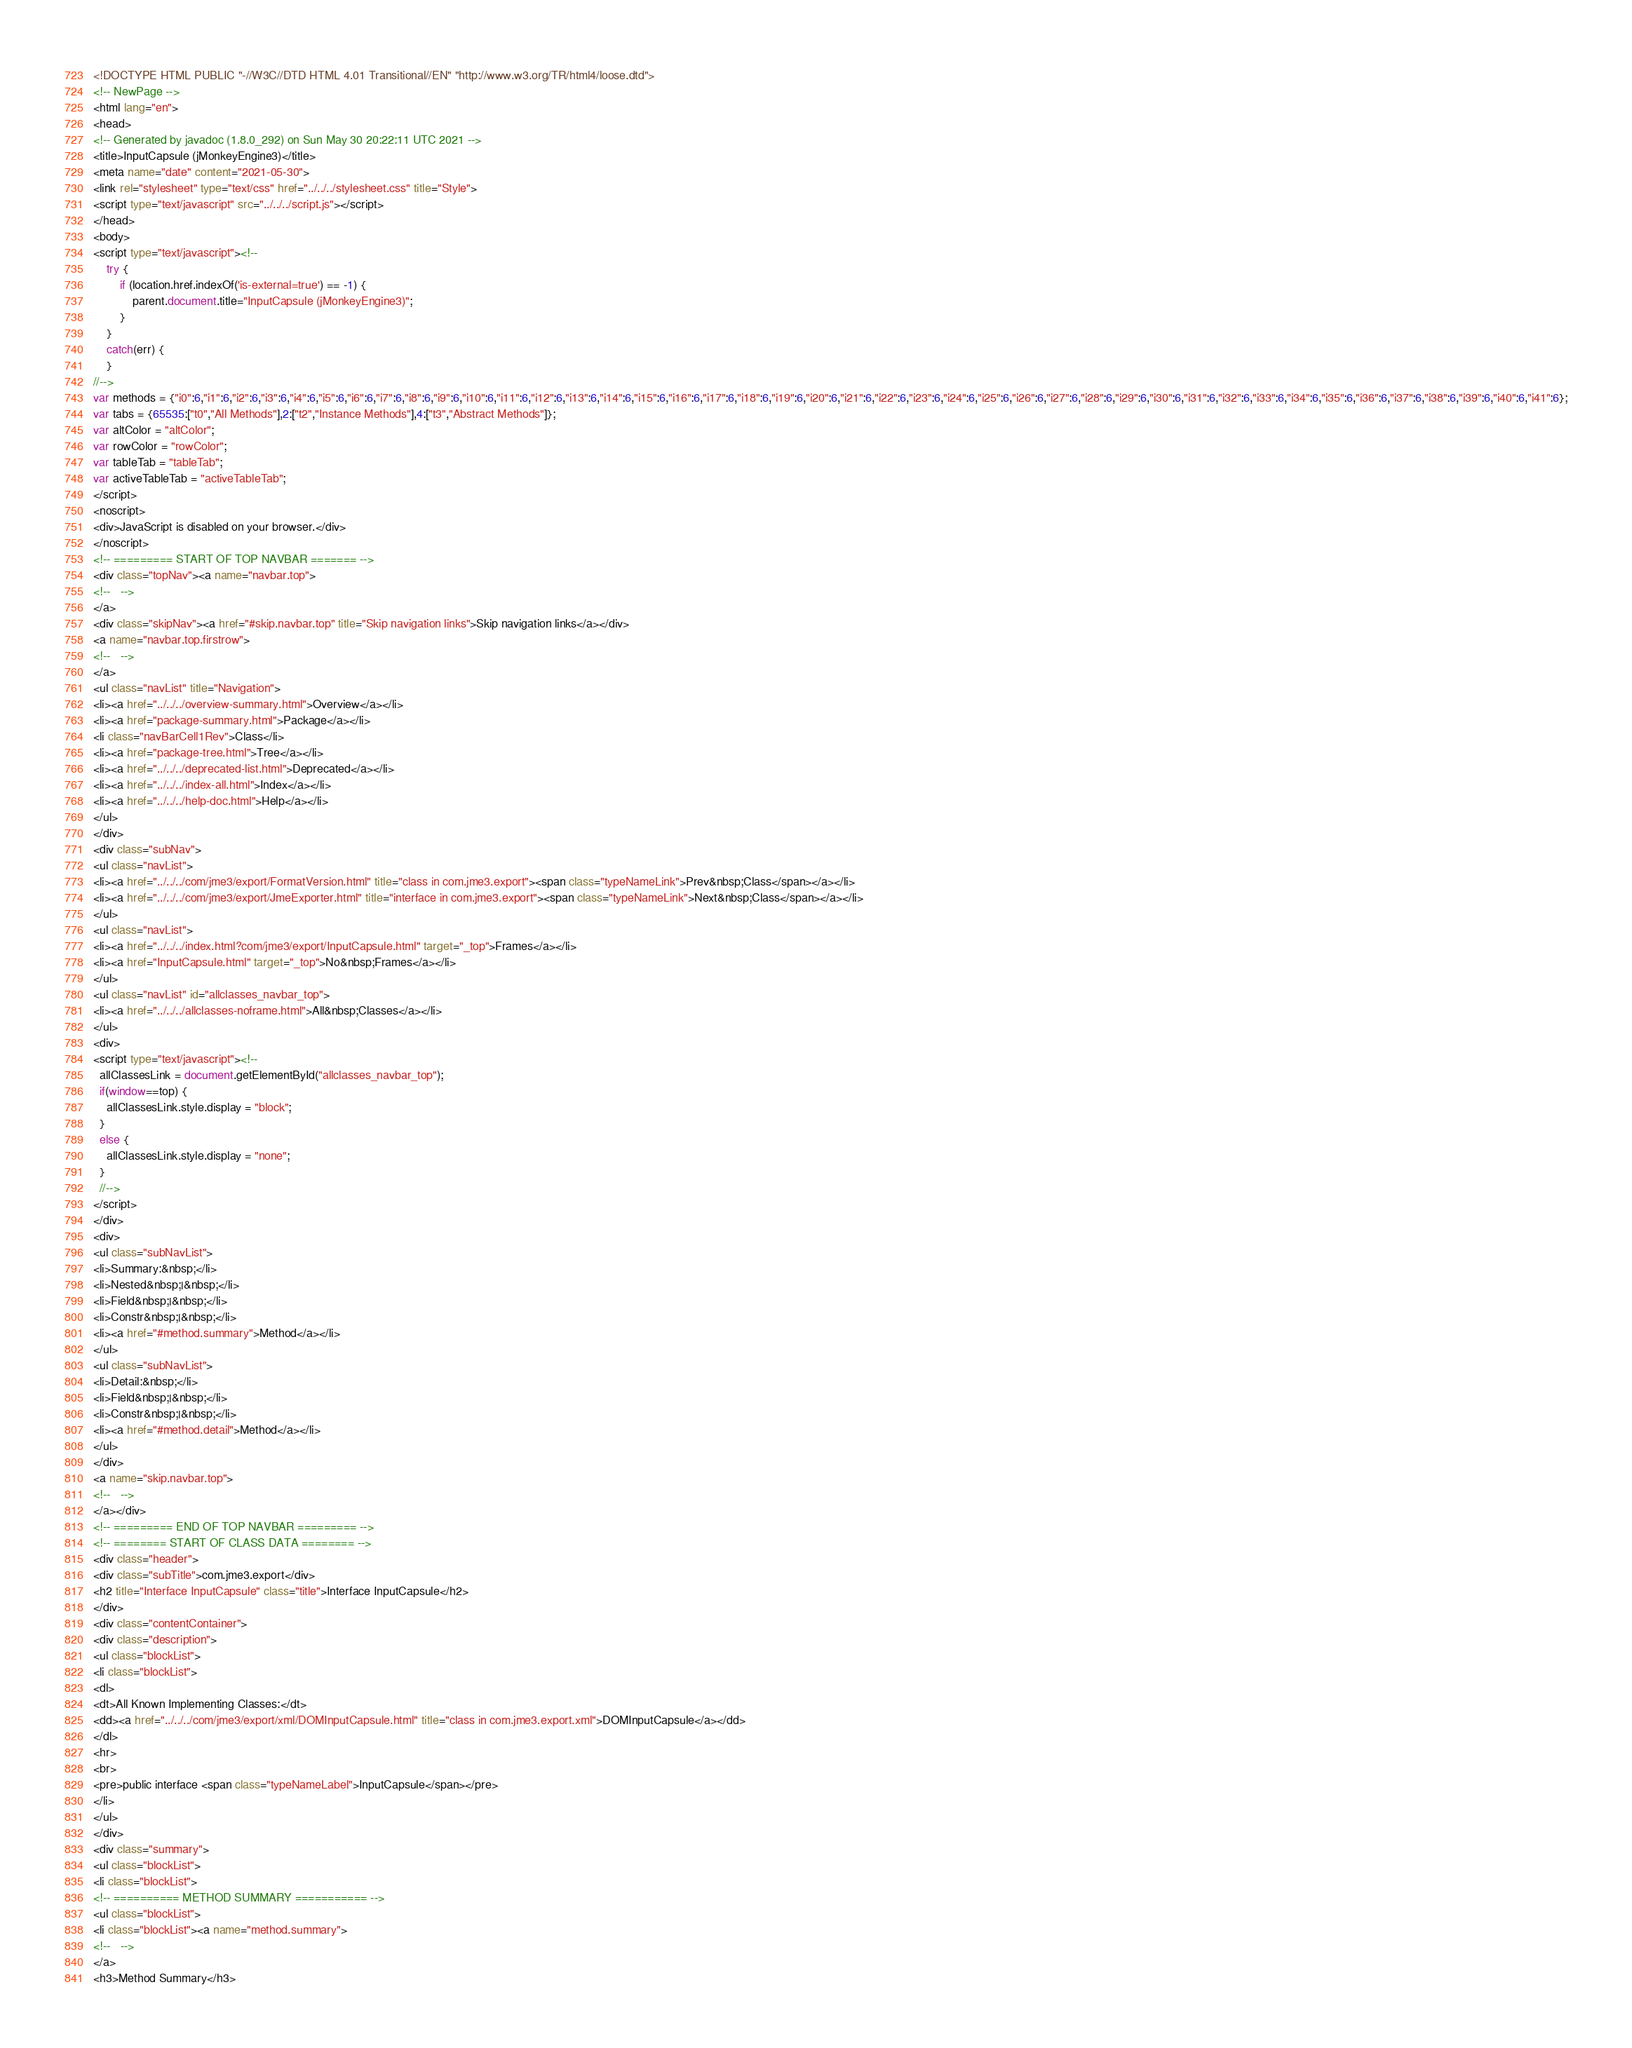<code> <loc_0><loc_0><loc_500><loc_500><_HTML_><!DOCTYPE HTML PUBLIC "-//W3C//DTD HTML 4.01 Transitional//EN" "http://www.w3.org/TR/html4/loose.dtd">
<!-- NewPage -->
<html lang="en">
<head>
<!-- Generated by javadoc (1.8.0_292) on Sun May 30 20:22:11 UTC 2021 -->
<title>InputCapsule (jMonkeyEngine3)</title>
<meta name="date" content="2021-05-30">
<link rel="stylesheet" type="text/css" href="../../../stylesheet.css" title="Style">
<script type="text/javascript" src="../../../script.js"></script>
</head>
<body>
<script type="text/javascript"><!--
    try {
        if (location.href.indexOf('is-external=true') == -1) {
            parent.document.title="InputCapsule (jMonkeyEngine3)";
        }
    }
    catch(err) {
    }
//-->
var methods = {"i0":6,"i1":6,"i2":6,"i3":6,"i4":6,"i5":6,"i6":6,"i7":6,"i8":6,"i9":6,"i10":6,"i11":6,"i12":6,"i13":6,"i14":6,"i15":6,"i16":6,"i17":6,"i18":6,"i19":6,"i20":6,"i21":6,"i22":6,"i23":6,"i24":6,"i25":6,"i26":6,"i27":6,"i28":6,"i29":6,"i30":6,"i31":6,"i32":6,"i33":6,"i34":6,"i35":6,"i36":6,"i37":6,"i38":6,"i39":6,"i40":6,"i41":6};
var tabs = {65535:["t0","All Methods"],2:["t2","Instance Methods"],4:["t3","Abstract Methods"]};
var altColor = "altColor";
var rowColor = "rowColor";
var tableTab = "tableTab";
var activeTableTab = "activeTableTab";
</script>
<noscript>
<div>JavaScript is disabled on your browser.</div>
</noscript>
<!-- ========= START OF TOP NAVBAR ======= -->
<div class="topNav"><a name="navbar.top">
<!--   -->
</a>
<div class="skipNav"><a href="#skip.navbar.top" title="Skip navigation links">Skip navigation links</a></div>
<a name="navbar.top.firstrow">
<!--   -->
</a>
<ul class="navList" title="Navigation">
<li><a href="../../../overview-summary.html">Overview</a></li>
<li><a href="package-summary.html">Package</a></li>
<li class="navBarCell1Rev">Class</li>
<li><a href="package-tree.html">Tree</a></li>
<li><a href="../../../deprecated-list.html">Deprecated</a></li>
<li><a href="../../../index-all.html">Index</a></li>
<li><a href="../../../help-doc.html">Help</a></li>
</ul>
</div>
<div class="subNav">
<ul class="navList">
<li><a href="../../../com/jme3/export/FormatVersion.html" title="class in com.jme3.export"><span class="typeNameLink">Prev&nbsp;Class</span></a></li>
<li><a href="../../../com/jme3/export/JmeExporter.html" title="interface in com.jme3.export"><span class="typeNameLink">Next&nbsp;Class</span></a></li>
</ul>
<ul class="navList">
<li><a href="../../../index.html?com/jme3/export/InputCapsule.html" target="_top">Frames</a></li>
<li><a href="InputCapsule.html" target="_top">No&nbsp;Frames</a></li>
</ul>
<ul class="navList" id="allclasses_navbar_top">
<li><a href="../../../allclasses-noframe.html">All&nbsp;Classes</a></li>
</ul>
<div>
<script type="text/javascript"><!--
  allClassesLink = document.getElementById("allclasses_navbar_top");
  if(window==top) {
    allClassesLink.style.display = "block";
  }
  else {
    allClassesLink.style.display = "none";
  }
  //-->
</script>
</div>
<div>
<ul class="subNavList">
<li>Summary:&nbsp;</li>
<li>Nested&nbsp;|&nbsp;</li>
<li>Field&nbsp;|&nbsp;</li>
<li>Constr&nbsp;|&nbsp;</li>
<li><a href="#method.summary">Method</a></li>
</ul>
<ul class="subNavList">
<li>Detail:&nbsp;</li>
<li>Field&nbsp;|&nbsp;</li>
<li>Constr&nbsp;|&nbsp;</li>
<li><a href="#method.detail">Method</a></li>
</ul>
</div>
<a name="skip.navbar.top">
<!--   -->
</a></div>
<!-- ========= END OF TOP NAVBAR ========= -->
<!-- ======== START OF CLASS DATA ======== -->
<div class="header">
<div class="subTitle">com.jme3.export</div>
<h2 title="Interface InputCapsule" class="title">Interface InputCapsule</h2>
</div>
<div class="contentContainer">
<div class="description">
<ul class="blockList">
<li class="blockList">
<dl>
<dt>All Known Implementing Classes:</dt>
<dd><a href="../../../com/jme3/export/xml/DOMInputCapsule.html" title="class in com.jme3.export.xml">DOMInputCapsule</a></dd>
</dl>
<hr>
<br>
<pre>public interface <span class="typeNameLabel">InputCapsule</span></pre>
</li>
</ul>
</div>
<div class="summary">
<ul class="blockList">
<li class="blockList">
<!-- ========== METHOD SUMMARY =========== -->
<ul class="blockList">
<li class="blockList"><a name="method.summary">
<!--   -->
</a>
<h3>Method Summary</h3></code> 